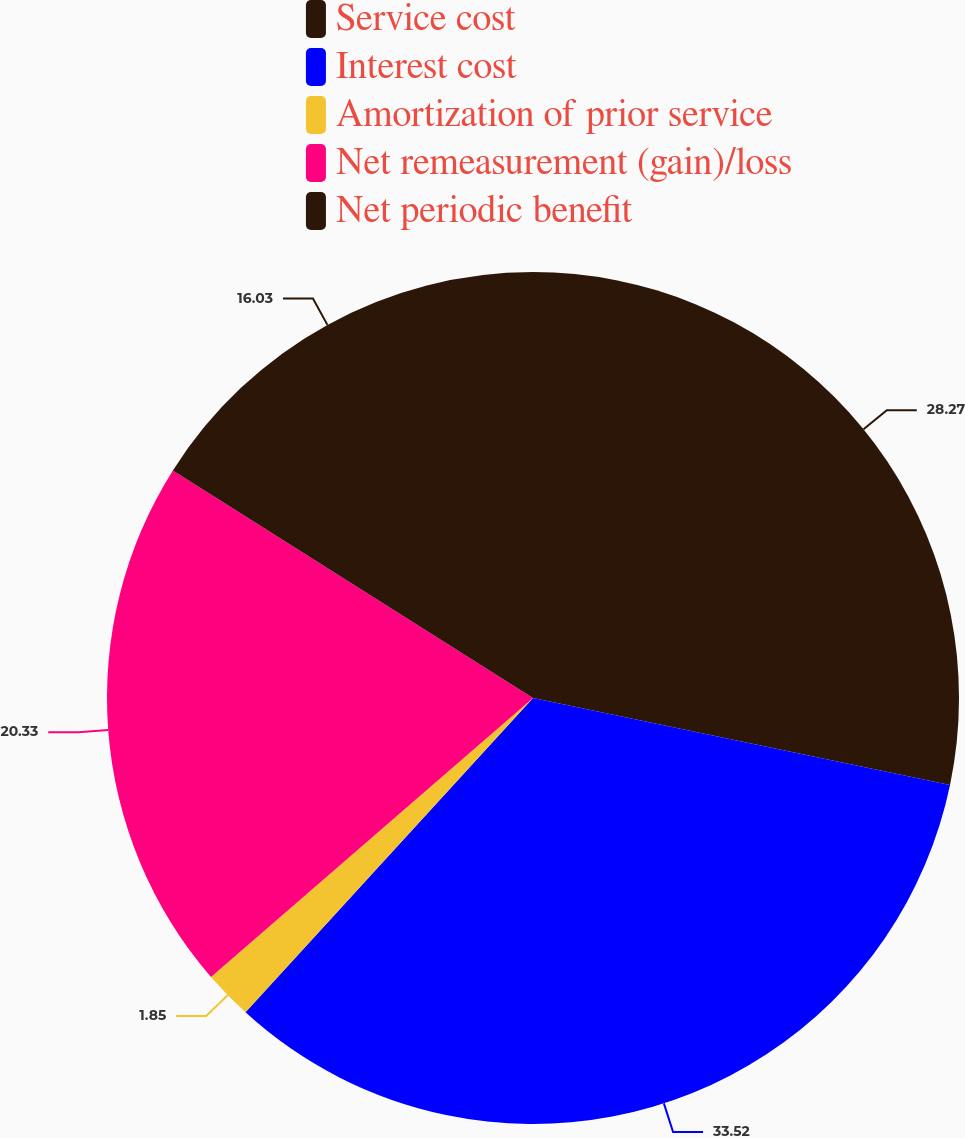<chart> <loc_0><loc_0><loc_500><loc_500><pie_chart><fcel>Service cost<fcel>Interest cost<fcel>Amortization of prior service<fcel>Net remeasurement (gain)/loss<fcel>Net periodic benefit<nl><fcel>28.27%<fcel>33.52%<fcel>1.85%<fcel>20.33%<fcel>16.03%<nl></chart> 